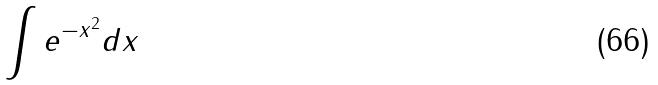Convert formula to latex. <formula><loc_0><loc_0><loc_500><loc_500>\int e ^ { - x ^ { 2 } } d x</formula> 